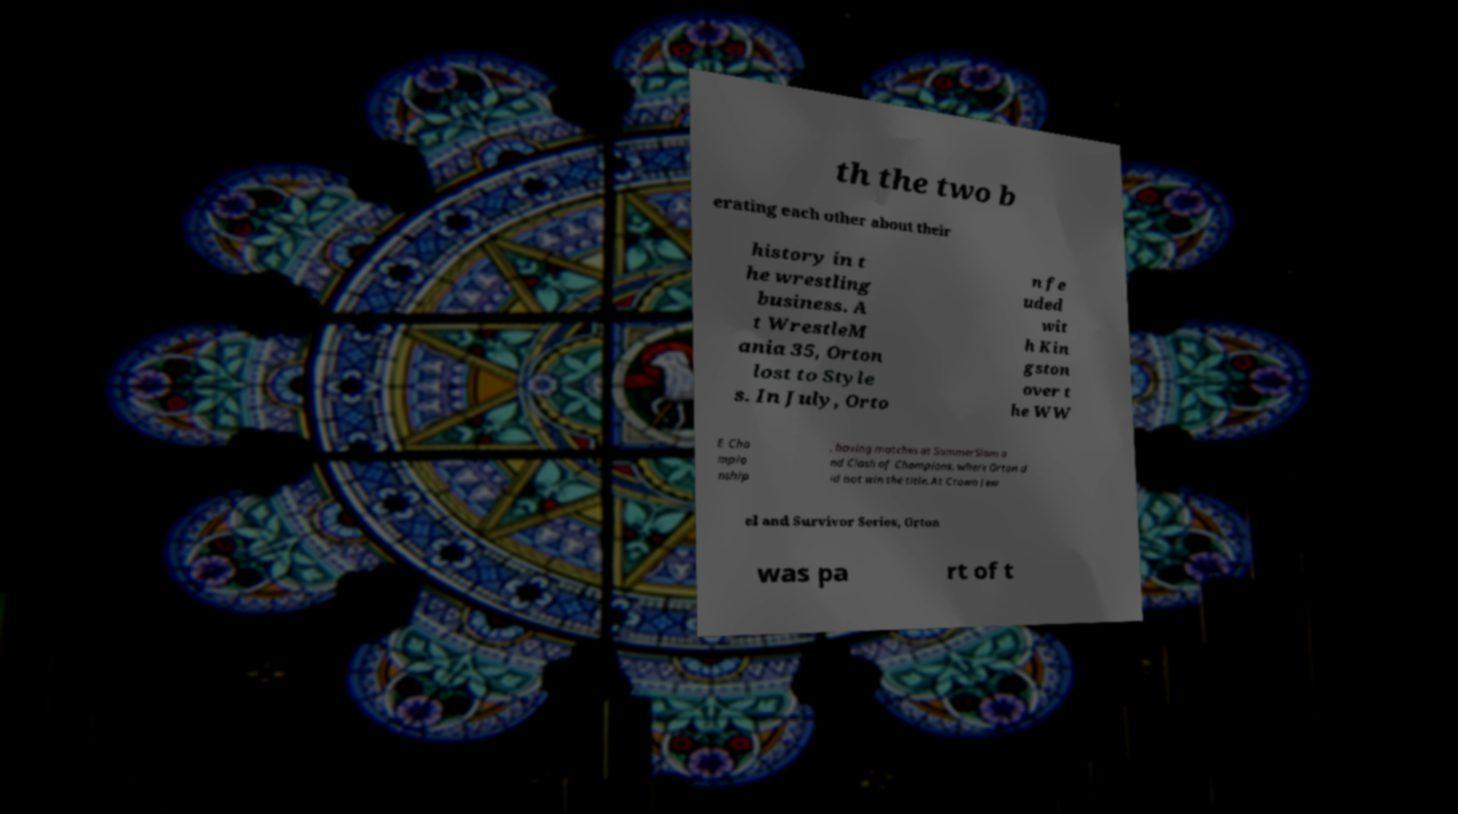Can you read and provide the text displayed in the image?This photo seems to have some interesting text. Can you extract and type it out for me? th the two b erating each other about their history in t he wrestling business. A t WrestleM ania 35, Orton lost to Style s. In July, Orto n fe uded wit h Kin gston over t he WW E Cha mpio nship , having matches at SummerSlam a nd Clash of Champions, where Orton d id not win the title. At Crown Jew el and Survivor Series, Orton was pa rt of t 